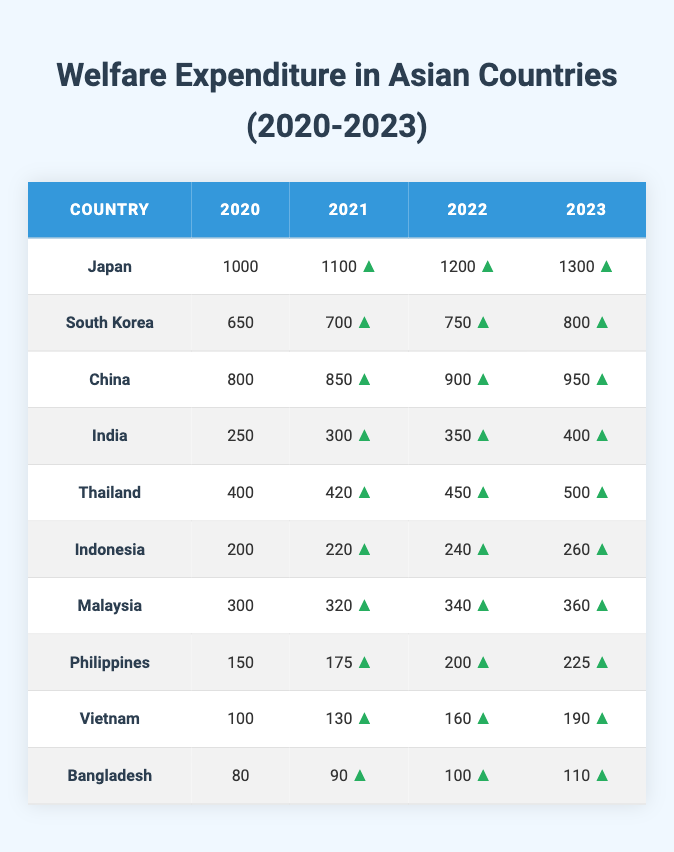What was the welfare expenditure of Japan in 2022? According to the table, Japan's welfare expenditure in 2022 is directly provided. We can see that it is listed as 1200.
Answer: 1200 Which country had the lowest welfare expenditure in 2020? From the table, we can see all the welfare expenditures listed for 2020. The lowest value is for Bangladesh, which is 80.
Answer: Bangladesh What is the total welfare expenditure of South Korea from 2020 to 2023? To find this, we sum the values for South Korea across the years: 650 (2020) + 700 (2021) + 750 (2022) + 800 (2023) = 2900.
Answer: 2900 Did India have a higher welfare expenditure in 2023 compared to the Philippines in the same year? Checking the table, India's expenditure in 2023 is 400, whereas the Philippines' expenditure is 225. Since 400 is greater than 225, the statement is true.
Answer: Yes What was the average annual welfare expenditure for Thailand from 2020 to 2023? The total expenditure for Thailand over these years is: 400 + 420 + 450 + 500 = 2270. There are 4 years, so the average is 2270 / 4 = 567.5.
Answer: 567.5 Which countries show a consistent increase in welfare expenditure from 2020 to 2023? By examining the table, we see each country's figures increased each year: Japan, South Korea, China, India, Thailand, Indonesia, Malaysia, Philippines, Vietnam, and Bangladesh all show a trend upwards each year.
Answer: All listed countries What is the percentage increase in welfare expenditure for Indonesia from 2020 to 2023? Indonesia's expenditure increased from 200 in 2020 to 260 in 2023. The increase is 260 - 200 = 60. To find the percentage, we calculate (60 / 200) * 100 = 30%.
Answer: 30% In which year did Vietnam see the highest annual growth in welfare expenditure? By calculating the annual growth rates: 30 (from 100 to 130), 30 (from 130 to 160), and 30 (from 160 to 190). Each year shows the same increase of 30, so there is no year with a highest growth rate.
Answer: No specific year What is the total welfare expenditure for all countries combined in 2021? To find this, we add all countries’ expenditures for 2021: 1100 (Japan) + 700 (South Korea) + 850 (China) + 300 (India) + 420 (Thailand) + 220 (Indonesia) + 320 (Malaysia) + 175 (Philippines) + 130 (Vietnam) + 90 (Bangladesh). The total equals 4075.
Answer: 4075 Is the welfare expenditure of Malaysia in 2022 more than the expenditure of Vietnam in 2023? Looking at the table, Malaysia's expenditure in 2022 is 340, and Vietnam's expenditure in 2023 is 190. Since 340 is greater than 190, the statement is true.
Answer: Yes 